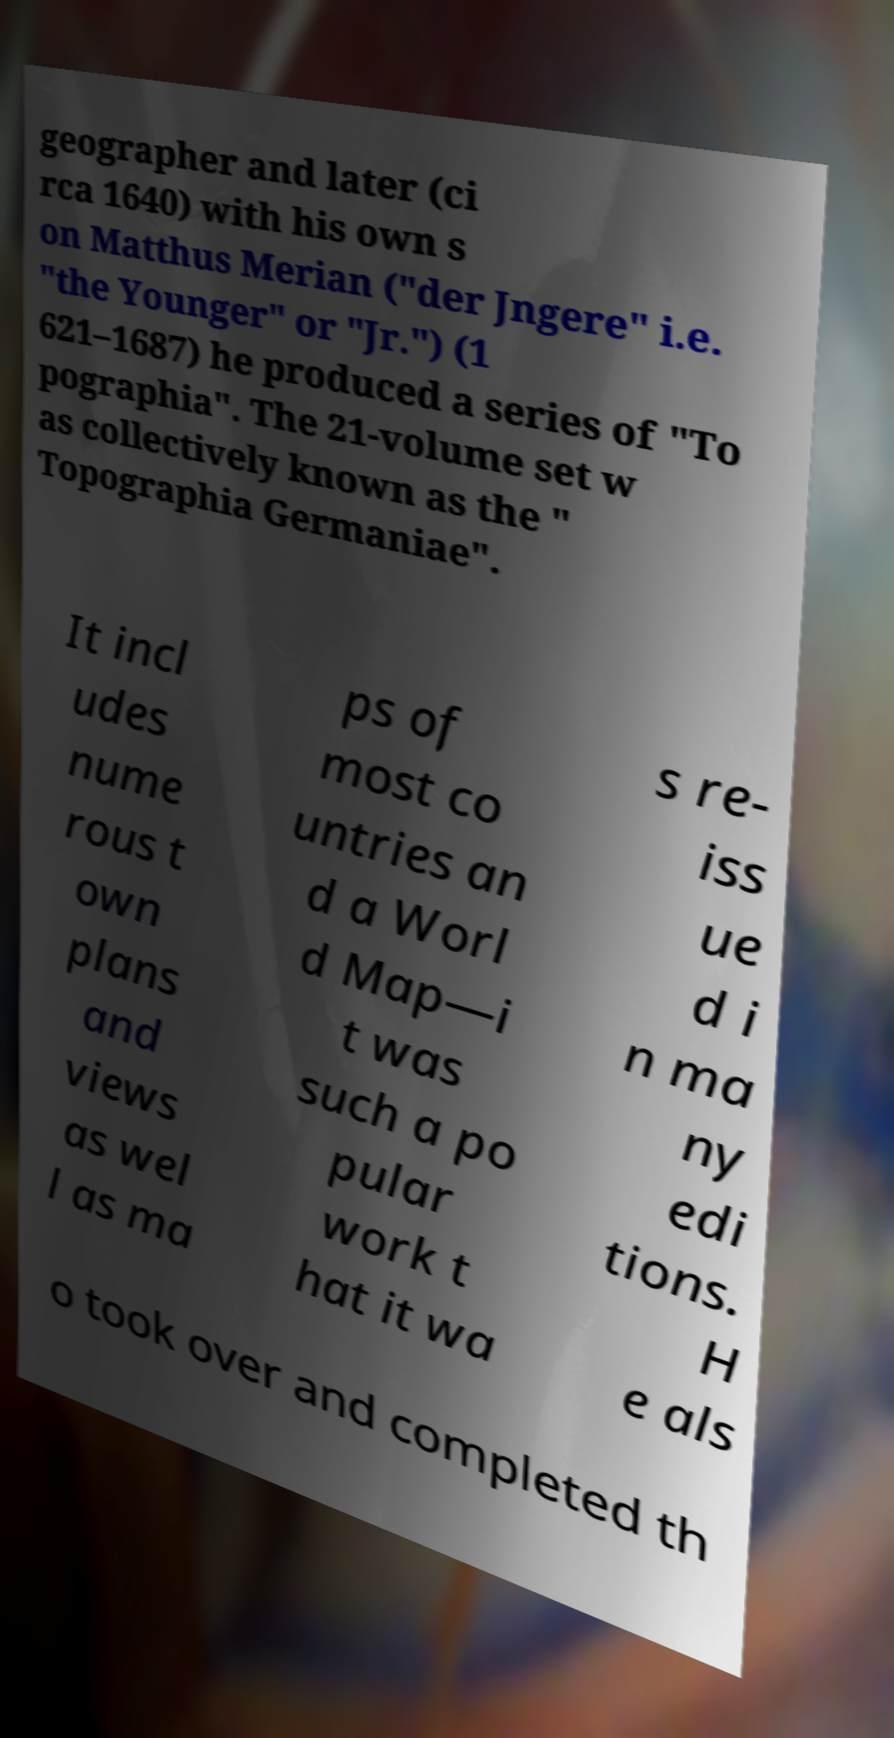There's text embedded in this image that I need extracted. Can you transcribe it verbatim? geographer and later (ci rca 1640) with his own s on Matthus Merian ("der Jngere" i.e. "the Younger" or "Jr.") (1 621–1687) he produced a series of "To pographia". The 21-volume set w as collectively known as the " Topographia Germaniae". It incl udes nume rous t own plans and views as wel l as ma ps of most co untries an d a Worl d Map—i t was such a po pular work t hat it wa s re- iss ue d i n ma ny edi tions. H e als o took over and completed th 